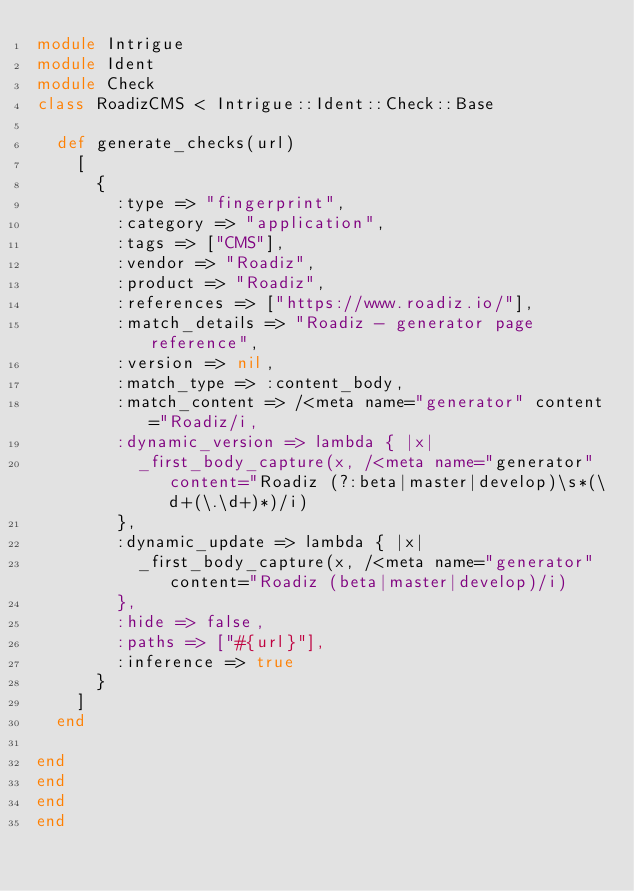<code> <loc_0><loc_0><loc_500><loc_500><_Ruby_>module Intrigue
module Ident
module Check
class RoadizCMS < Intrigue::Ident::Check::Base

  def generate_checks(url)
    [
      {
        :type => "fingerprint",
        :category => "application",
        :tags => ["CMS"],
        :vendor => "Roadiz",
        :product => "Roadiz",
        :references => ["https://www.roadiz.io/"],
        :match_details => "Roadiz - generator page reference",
        :version => nil,
        :match_type => :content_body,
        :match_content => /<meta name="generator" content="Roadiz/i,
        :dynamic_version => lambda { |x| 
          _first_body_capture(x, /<meta name="generator" content="Roadiz (?:beta|master|develop)\s*(\d+(\.\d+)*)/i)
        },
        :dynamic_update => lambda { |x| 
          _first_body_capture(x, /<meta name="generator" content="Roadiz (beta|master|develop)/i)
        },
        :hide => false,
        :paths => ["#{url}"],
        :inference => true
      }
    ]
  end

end
end
end
end
</code> 